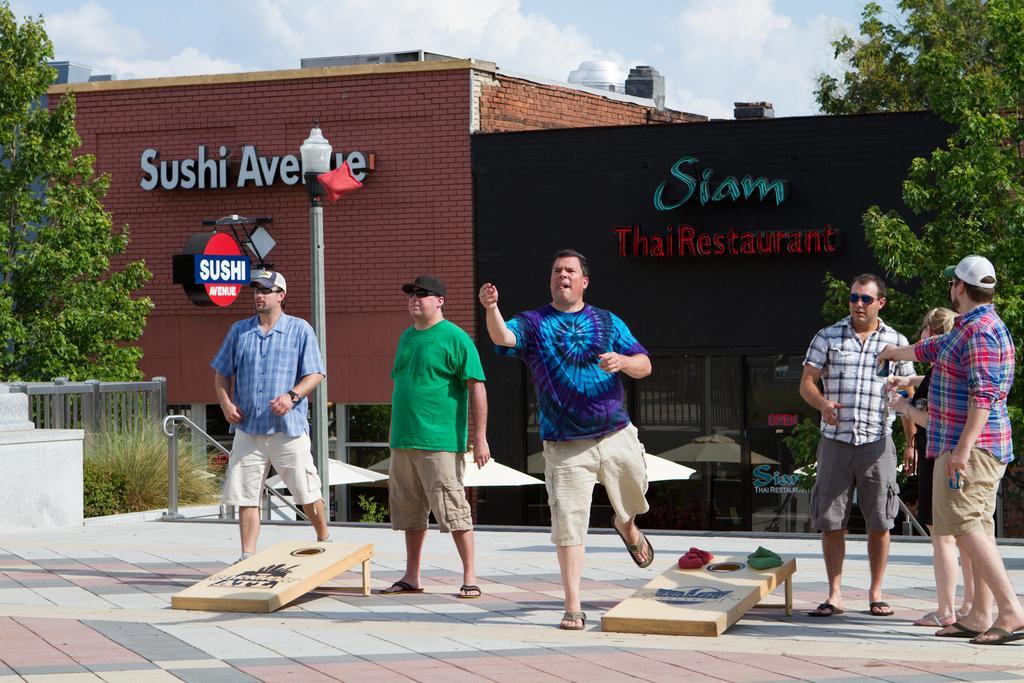How would you summarize this image in a sentence or two? In this image there are a few people standing, beside them on the floor there is a wooden plank with some objects on it, behind them there are metal rod fence, poles, trees, tents and buildings, on the buildings there are name boards. 